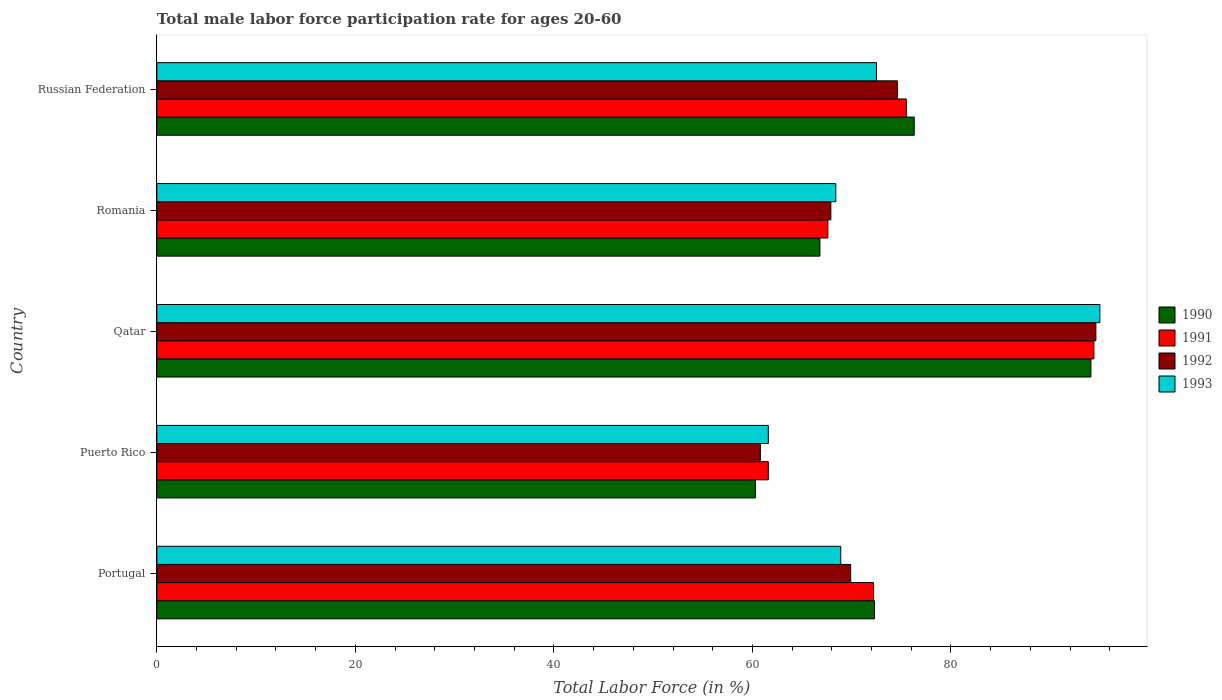How many groups of bars are there?
Provide a short and direct response. 5. Are the number of bars on each tick of the Y-axis equal?
Offer a very short reply. Yes. How many bars are there on the 3rd tick from the top?
Provide a succinct answer. 4. What is the label of the 1st group of bars from the top?
Offer a very short reply. Russian Federation. What is the male labor force participation rate in 1991 in Puerto Rico?
Give a very brief answer. 61.6. Across all countries, what is the maximum male labor force participation rate in 1992?
Provide a short and direct response. 94.6. Across all countries, what is the minimum male labor force participation rate in 1991?
Keep it short and to the point. 61.6. In which country was the male labor force participation rate in 1993 maximum?
Provide a succinct answer. Qatar. In which country was the male labor force participation rate in 1990 minimum?
Provide a succinct answer. Puerto Rico. What is the total male labor force participation rate in 1990 in the graph?
Offer a terse response. 369.8. What is the difference between the male labor force participation rate in 1993 in Puerto Rico and that in Qatar?
Give a very brief answer. -33.4. What is the difference between the male labor force participation rate in 1993 in Russian Federation and the male labor force participation rate in 1991 in Puerto Rico?
Ensure brevity in your answer.  10.9. What is the average male labor force participation rate in 1990 per country?
Provide a succinct answer. 73.96. What is the difference between the male labor force participation rate in 1992 and male labor force participation rate in 1990 in Russian Federation?
Keep it short and to the point. -1.7. In how many countries, is the male labor force participation rate in 1991 greater than 68 %?
Keep it short and to the point. 3. What is the ratio of the male labor force participation rate in 1991 in Puerto Rico to that in Romania?
Ensure brevity in your answer.  0.91. Is the male labor force participation rate in 1993 in Portugal less than that in Romania?
Make the answer very short. No. What is the difference between the highest and the second highest male labor force participation rate in 1993?
Make the answer very short. 22.5. What is the difference between the highest and the lowest male labor force participation rate in 1992?
Offer a terse response. 33.8. In how many countries, is the male labor force participation rate in 1993 greater than the average male labor force participation rate in 1993 taken over all countries?
Keep it short and to the point. 1. Is it the case that in every country, the sum of the male labor force participation rate in 1991 and male labor force participation rate in 1992 is greater than the sum of male labor force participation rate in 1993 and male labor force participation rate in 1990?
Give a very brief answer. No. What does the 4th bar from the top in Puerto Rico represents?
Ensure brevity in your answer.  1990. What does the 4th bar from the bottom in Russian Federation represents?
Provide a short and direct response. 1993. Are all the bars in the graph horizontal?
Give a very brief answer. Yes. Where does the legend appear in the graph?
Your answer should be compact. Center right. How many legend labels are there?
Keep it short and to the point. 4. What is the title of the graph?
Keep it short and to the point. Total male labor force participation rate for ages 20-60. Does "1990" appear as one of the legend labels in the graph?
Your response must be concise. Yes. What is the label or title of the X-axis?
Ensure brevity in your answer.  Total Labor Force (in %). What is the label or title of the Y-axis?
Ensure brevity in your answer.  Country. What is the Total Labor Force (in %) of 1990 in Portugal?
Provide a short and direct response. 72.3. What is the Total Labor Force (in %) in 1991 in Portugal?
Provide a succinct answer. 72.2. What is the Total Labor Force (in %) of 1992 in Portugal?
Your response must be concise. 69.9. What is the Total Labor Force (in %) of 1993 in Portugal?
Make the answer very short. 68.9. What is the Total Labor Force (in %) in 1990 in Puerto Rico?
Provide a short and direct response. 60.3. What is the Total Labor Force (in %) of 1991 in Puerto Rico?
Your answer should be compact. 61.6. What is the Total Labor Force (in %) of 1992 in Puerto Rico?
Offer a very short reply. 60.8. What is the Total Labor Force (in %) in 1993 in Puerto Rico?
Your answer should be very brief. 61.6. What is the Total Labor Force (in %) of 1990 in Qatar?
Your answer should be compact. 94.1. What is the Total Labor Force (in %) in 1991 in Qatar?
Keep it short and to the point. 94.4. What is the Total Labor Force (in %) in 1992 in Qatar?
Keep it short and to the point. 94.6. What is the Total Labor Force (in %) of 1990 in Romania?
Give a very brief answer. 66.8. What is the Total Labor Force (in %) in 1991 in Romania?
Your answer should be compact. 67.6. What is the Total Labor Force (in %) in 1992 in Romania?
Ensure brevity in your answer.  67.9. What is the Total Labor Force (in %) in 1993 in Romania?
Your response must be concise. 68.4. What is the Total Labor Force (in %) in 1990 in Russian Federation?
Keep it short and to the point. 76.3. What is the Total Labor Force (in %) of 1991 in Russian Federation?
Offer a very short reply. 75.5. What is the Total Labor Force (in %) of 1992 in Russian Federation?
Offer a terse response. 74.6. What is the Total Labor Force (in %) in 1993 in Russian Federation?
Offer a very short reply. 72.5. Across all countries, what is the maximum Total Labor Force (in %) of 1990?
Your response must be concise. 94.1. Across all countries, what is the maximum Total Labor Force (in %) of 1991?
Offer a terse response. 94.4. Across all countries, what is the maximum Total Labor Force (in %) of 1992?
Offer a terse response. 94.6. Across all countries, what is the maximum Total Labor Force (in %) in 1993?
Ensure brevity in your answer.  95. Across all countries, what is the minimum Total Labor Force (in %) of 1990?
Make the answer very short. 60.3. Across all countries, what is the minimum Total Labor Force (in %) of 1991?
Your response must be concise. 61.6. Across all countries, what is the minimum Total Labor Force (in %) in 1992?
Ensure brevity in your answer.  60.8. Across all countries, what is the minimum Total Labor Force (in %) in 1993?
Provide a succinct answer. 61.6. What is the total Total Labor Force (in %) in 1990 in the graph?
Provide a succinct answer. 369.8. What is the total Total Labor Force (in %) in 1991 in the graph?
Ensure brevity in your answer.  371.3. What is the total Total Labor Force (in %) in 1992 in the graph?
Keep it short and to the point. 367.8. What is the total Total Labor Force (in %) in 1993 in the graph?
Make the answer very short. 366.4. What is the difference between the Total Labor Force (in %) of 1992 in Portugal and that in Puerto Rico?
Your answer should be compact. 9.1. What is the difference between the Total Labor Force (in %) in 1993 in Portugal and that in Puerto Rico?
Your answer should be very brief. 7.3. What is the difference between the Total Labor Force (in %) in 1990 in Portugal and that in Qatar?
Keep it short and to the point. -21.8. What is the difference between the Total Labor Force (in %) of 1991 in Portugal and that in Qatar?
Your answer should be very brief. -22.2. What is the difference between the Total Labor Force (in %) in 1992 in Portugal and that in Qatar?
Give a very brief answer. -24.7. What is the difference between the Total Labor Force (in %) in 1993 in Portugal and that in Qatar?
Offer a terse response. -26.1. What is the difference between the Total Labor Force (in %) in 1990 in Portugal and that in Romania?
Make the answer very short. 5.5. What is the difference between the Total Labor Force (in %) of 1993 in Portugal and that in Romania?
Make the answer very short. 0.5. What is the difference between the Total Labor Force (in %) of 1990 in Puerto Rico and that in Qatar?
Your response must be concise. -33.8. What is the difference between the Total Labor Force (in %) of 1991 in Puerto Rico and that in Qatar?
Provide a succinct answer. -32.8. What is the difference between the Total Labor Force (in %) of 1992 in Puerto Rico and that in Qatar?
Offer a terse response. -33.8. What is the difference between the Total Labor Force (in %) in 1993 in Puerto Rico and that in Qatar?
Your answer should be compact. -33.4. What is the difference between the Total Labor Force (in %) of 1990 in Puerto Rico and that in Romania?
Ensure brevity in your answer.  -6.5. What is the difference between the Total Labor Force (in %) in 1991 in Puerto Rico and that in Romania?
Provide a short and direct response. -6. What is the difference between the Total Labor Force (in %) of 1991 in Puerto Rico and that in Russian Federation?
Make the answer very short. -13.9. What is the difference between the Total Labor Force (in %) in 1993 in Puerto Rico and that in Russian Federation?
Your response must be concise. -10.9. What is the difference between the Total Labor Force (in %) of 1990 in Qatar and that in Romania?
Provide a succinct answer. 27.3. What is the difference between the Total Labor Force (in %) of 1991 in Qatar and that in Romania?
Provide a succinct answer. 26.8. What is the difference between the Total Labor Force (in %) in 1992 in Qatar and that in Romania?
Provide a short and direct response. 26.7. What is the difference between the Total Labor Force (in %) in 1993 in Qatar and that in Romania?
Your answer should be very brief. 26.6. What is the difference between the Total Labor Force (in %) of 1990 in Qatar and that in Russian Federation?
Your response must be concise. 17.8. What is the difference between the Total Labor Force (in %) in 1991 in Qatar and that in Russian Federation?
Your response must be concise. 18.9. What is the difference between the Total Labor Force (in %) of 1991 in Romania and that in Russian Federation?
Your answer should be compact. -7.9. What is the difference between the Total Labor Force (in %) of 1993 in Romania and that in Russian Federation?
Offer a very short reply. -4.1. What is the difference between the Total Labor Force (in %) in 1990 in Portugal and the Total Labor Force (in %) in 1991 in Puerto Rico?
Provide a short and direct response. 10.7. What is the difference between the Total Labor Force (in %) in 1991 in Portugal and the Total Labor Force (in %) in 1992 in Puerto Rico?
Offer a terse response. 11.4. What is the difference between the Total Labor Force (in %) in 1991 in Portugal and the Total Labor Force (in %) in 1993 in Puerto Rico?
Ensure brevity in your answer.  10.6. What is the difference between the Total Labor Force (in %) of 1990 in Portugal and the Total Labor Force (in %) of 1991 in Qatar?
Your answer should be very brief. -22.1. What is the difference between the Total Labor Force (in %) of 1990 in Portugal and the Total Labor Force (in %) of 1992 in Qatar?
Offer a terse response. -22.3. What is the difference between the Total Labor Force (in %) of 1990 in Portugal and the Total Labor Force (in %) of 1993 in Qatar?
Give a very brief answer. -22.7. What is the difference between the Total Labor Force (in %) of 1991 in Portugal and the Total Labor Force (in %) of 1992 in Qatar?
Offer a terse response. -22.4. What is the difference between the Total Labor Force (in %) of 1991 in Portugal and the Total Labor Force (in %) of 1993 in Qatar?
Make the answer very short. -22.8. What is the difference between the Total Labor Force (in %) of 1992 in Portugal and the Total Labor Force (in %) of 1993 in Qatar?
Provide a succinct answer. -25.1. What is the difference between the Total Labor Force (in %) in 1990 in Portugal and the Total Labor Force (in %) in 1991 in Romania?
Offer a very short reply. 4.7. What is the difference between the Total Labor Force (in %) of 1990 in Portugal and the Total Labor Force (in %) of 1993 in Romania?
Keep it short and to the point. 3.9. What is the difference between the Total Labor Force (in %) in 1991 in Portugal and the Total Labor Force (in %) in 1992 in Romania?
Ensure brevity in your answer.  4.3. What is the difference between the Total Labor Force (in %) in 1991 in Portugal and the Total Labor Force (in %) in 1993 in Romania?
Offer a very short reply. 3.8. What is the difference between the Total Labor Force (in %) of 1992 in Portugal and the Total Labor Force (in %) of 1993 in Romania?
Keep it short and to the point. 1.5. What is the difference between the Total Labor Force (in %) in 1990 in Portugal and the Total Labor Force (in %) in 1991 in Russian Federation?
Give a very brief answer. -3.2. What is the difference between the Total Labor Force (in %) of 1990 in Portugal and the Total Labor Force (in %) of 1992 in Russian Federation?
Ensure brevity in your answer.  -2.3. What is the difference between the Total Labor Force (in %) in 1990 in Portugal and the Total Labor Force (in %) in 1993 in Russian Federation?
Your response must be concise. -0.2. What is the difference between the Total Labor Force (in %) in 1991 in Portugal and the Total Labor Force (in %) in 1992 in Russian Federation?
Your response must be concise. -2.4. What is the difference between the Total Labor Force (in %) of 1992 in Portugal and the Total Labor Force (in %) of 1993 in Russian Federation?
Offer a terse response. -2.6. What is the difference between the Total Labor Force (in %) of 1990 in Puerto Rico and the Total Labor Force (in %) of 1991 in Qatar?
Provide a short and direct response. -34.1. What is the difference between the Total Labor Force (in %) in 1990 in Puerto Rico and the Total Labor Force (in %) in 1992 in Qatar?
Provide a succinct answer. -34.3. What is the difference between the Total Labor Force (in %) of 1990 in Puerto Rico and the Total Labor Force (in %) of 1993 in Qatar?
Make the answer very short. -34.7. What is the difference between the Total Labor Force (in %) of 1991 in Puerto Rico and the Total Labor Force (in %) of 1992 in Qatar?
Keep it short and to the point. -33. What is the difference between the Total Labor Force (in %) of 1991 in Puerto Rico and the Total Labor Force (in %) of 1993 in Qatar?
Ensure brevity in your answer.  -33.4. What is the difference between the Total Labor Force (in %) in 1992 in Puerto Rico and the Total Labor Force (in %) in 1993 in Qatar?
Make the answer very short. -34.2. What is the difference between the Total Labor Force (in %) in 1990 in Puerto Rico and the Total Labor Force (in %) in 1992 in Romania?
Ensure brevity in your answer.  -7.6. What is the difference between the Total Labor Force (in %) in 1990 in Puerto Rico and the Total Labor Force (in %) in 1993 in Romania?
Ensure brevity in your answer.  -8.1. What is the difference between the Total Labor Force (in %) in 1991 in Puerto Rico and the Total Labor Force (in %) in 1993 in Romania?
Offer a very short reply. -6.8. What is the difference between the Total Labor Force (in %) in 1992 in Puerto Rico and the Total Labor Force (in %) in 1993 in Romania?
Keep it short and to the point. -7.6. What is the difference between the Total Labor Force (in %) in 1990 in Puerto Rico and the Total Labor Force (in %) in 1991 in Russian Federation?
Provide a short and direct response. -15.2. What is the difference between the Total Labor Force (in %) in 1990 in Puerto Rico and the Total Labor Force (in %) in 1992 in Russian Federation?
Provide a succinct answer. -14.3. What is the difference between the Total Labor Force (in %) in 1990 in Puerto Rico and the Total Labor Force (in %) in 1993 in Russian Federation?
Your response must be concise. -12.2. What is the difference between the Total Labor Force (in %) of 1990 in Qatar and the Total Labor Force (in %) of 1992 in Romania?
Offer a terse response. 26.2. What is the difference between the Total Labor Force (in %) of 1990 in Qatar and the Total Labor Force (in %) of 1993 in Romania?
Offer a terse response. 25.7. What is the difference between the Total Labor Force (in %) of 1992 in Qatar and the Total Labor Force (in %) of 1993 in Romania?
Your answer should be very brief. 26.2. What is the difference between the Total Labor Force (in %) of 1990 in Qatar and the Total Labor Force (in %) of 1992 in Russian Federation?
Your answer should be compact. 19.5. What is the difference between the Total Labor Force (in %) of 1990 in Qatar and the Total Labor Force (in %) of 1993 in Russian Federation?
Make the answer very short. 21.6. What is the difference between the Total Labor Force (in %) of 1991 in Qatar and the Total Labor Force (in %) of 1992 in Russian Federation?
Ensure brevity in your answer.  19.8. What is the difference between the Total Labor Force (in %) of 1991 in Qatar and the Total Labor Force (in %) of 1993 in Russian Federation?
Keep it short and to the point. 21.9. What is the difference between the Total Labor Force (in %) of 1992 in Qatar and the Total Labor Force (in %) of 1993 in Russian Federation?
Make the answer very short. 22.1. What is the difference between the Total Labor Force (in %) of 1990 in Romania and the Total Labor Force (in %) of 1993 in Russian Federation?
Offer a very short reply. -5.7. What is the difference between the Total Labor Force (in %) in 1991 in Romania and the Total Labor Force (in %) in 1992 in Russian Federation?
Give a very brief answer. -7. What is the average Total Labor Force (in %) in 1990 per country?
Ensure brevity in your answer.  73.96. What is the average Total Labor Force (in %) in 1991 per country?
Give a very brief answer. 74.26. What is the average Total Labor Force (in %) in 1992 per country?
Offer a very short reply. 73.56. What is the average Total Labor Force (in %) of 1993 per country?
Your answer should be compact. 73.28. What is the difference between the Total Labor Force (in %) in 1990 and Total Labor Force (in %) in 1991 in Portugal?
Provide a short and direct response. 0.1. What is the difference between the Total Labor Force (in %) in 1990 and Total Labor Force (in %) in 1992 in Portugal?
Make the answer very short. 2.4. What is the difference between the Total Labor Force (in %) in 1992 and Total Labor Force (in %) in 1993 in Portugal?
Provide a succinct answer. 1. What is the difference between the Total Labor Force (in %) of 1990 and Total Labor Force (in %) of 1991 in Puerto Rico?
Your response must be concise. -1.3. What is the difference between the Total Labor Force (in %) in 1991 and Total Labor Force (in %) in 1992 in Puerto Rico?
Make the answer very short. 0.8. What is the difference between the Total Labor Force (in %) of 1992 and Total Labor Force (in %) of 1993 in Puerto Rico?
Your answer should be very brief. -0.8. What is the difference between the Total Labor Force (in %) in 1991 and Total Labor Force (in %) in 1992 in Qatar?
Your response must be concise. -0.2. What is the difference between the Total Labor Force (in %) in 1992 and Total Labor Force (in %) in 1993 in Qatar?
Keep it short and to the point. -0.4. What is the difference between the Total Labor Force (in %) of 1990 and Total Labor Force (in %) of 1991 in Romania?
Your response must be concise. -0.8. What is the difference between the Total Labor Force (in %) in 1991 and Total Labor Force (in %) in 1992 in Romania?
Offer a terse response. -0.3. What is the difference between the Total Labor Force (in %) of 1991 and Total Labor Force (in %) of 1993 in Romania?
Your answer should be compact. -0.8. What is the difference between the Total Labor Force (in %) of 1990 and Total Labor Force (in %) of 1991 in Russian Federation?
Your answer should be compact. 0.8. What is the difference between the Total Labor Force (in %) of 1990 and Total Labor Force (in %) of 1993 in Russian Federation?
Give a very brief answer. 3.8. What is the ratio of the Total Labor Force (in %) in 1990 in Portugal to that in Puerto Rico?
Your answer should be compact. 1.2. What is the ratio of the Total Labor Force (in %) in 1991 in Portugal to that in Puerto Rico?
Keep it short and to the point. 1.17. What is the ratio of the Total Labor Force (in %) of 1992 in Portugal to that in Puerto Rico?
Ensure brevity in your answer.  1.15. What is the ratio of the Total Labor Force (in %) in 1993 in Portugal to that in Puerto Rico?
Keep it short and to the point. 1.12. What is the ratio of the Total Labor Force (in %) in 1990 in Portugal to that in Qatar?
Provide a short and direct response. 0.77. What is the ratio of the Total Labor Force (in %) of 1991 in Portugal to that in Qatar?
Keep it short and to the point. 0.76. What is the ratio of the Total Labor Force (in %) in 1992 in Portugal to that in Qatar?
Your answer should be compact. 0.74. What is the ratio of the Total Labor Force (in %) of 1993 in Portugal to that in Qatar?
Keep it short and to the point. 0.73. What is the ratio of the Total Labor Force (in %) in 1990 in Portugal to that in Romania?
Your response must be concise. 1.08. What is the ratio of the Total Labor Force (in %) in 1991 in Portugal to that in Romania?
Your response must be concise. 1.07. What is the ratio of the Total Labor Force (in %) of 1992 in Portugal to that in Romania?
Keep it short and to the point. 1.03. What is the ratio of the Total Labor Force (in %) of 1993 in Portugal to that in Romania?
Your response must be concise. 1.01. What is the ratio of the Total Labor Force (in %) in 1990 in Portugal to that in Russian Federation?
Ensure brevity in your answer.  0.95. What is the ratio of the Total Labor Force (in %) in 1991 in Portugal to that in Russian Federation?
Your answer should be very brief. 0.96. What is the ratio of the Total Labor Force (in %) in 1992 in Portugal to that in Russian Federation?
Ensure brevity in your answer.  0.94. What is the ratio of the Total Labor Force (in %) in 1993 in Portugal to that in Russian Federation?
Your answer should be compact. 0.95. What is the ratio of the Total Labor Force (in %) in 1990 in Puerto Rico to that in Qatar?
Your answer should be compact. 0.64. What is the ratio of the Total Labor Force (in %) of 1991 in Puerto Rico to that in Qatar?
Your response must be concise. 0.65. What is the ratio of the Total Labor Force (in %) of 1992 in Puerto Rico to that in Qatar?
Keep it short and to the point. 0.64. What is the ratio of the Total Labor Force (in %) in 1993 in Puerto Rico to that in Qatar?
Ensure brevity in your answer.  0.65. What is the ratio of the Total Labor Force (in %) in 1990 in Puerto Rico to that in Romania?
Provide a succinct answer. 0.9. What is the ratio of the Total Labor Force (in %) of 1991 in Puerto Rico to that in Romania?
Your answer should be very brief. 0.91. What is the ratio of the Total Labor Force (in %) of 1992 in Puerto Rico to that in Romania?
Make the answer very short. 0.9. What is the ratio of the Total Labor Force (in %) of 1993 in Puerto Rico to that in Romania?
Ensure brevity in your answer.  0.9. What is the ratio of the Total Labor Force (in %) of 1990 in Puerto Rico to that in Russian Federation?
Give a very brief answer. 0.79. What is the ratio of the Total Labor Force (in %) in 1991 in Puerto Rico to that in Russian Federation?
Provide a short and direct response. 0.82. What is the ratio of the Total Labor Force (in %) of 1992 in Puerto Rico to that in Russian Federation?
Offer a terse response. 0.81. What is the ratio of the Total Labor Force (in %) of 1993 in Puerto Rico to that in Russian Federation?
Your response must be concise. 0.85. What is the ratio of the Total Labor Force (in %) of 1990 in Qatar to that in Romania?
Ensure brevity in your answer.  1.41. What is the ratio of the Total Labor Force (in %) of 1991 in Qatar to that in Romania?
Provide a short and direct response. 1.4. What is the ratio of the Total Labor Force (in %) of 1992 in Qatar to that in Romania?
Give a very brief answer. 1.39. What is the ratio of the Total Labor Force (in %) in 1993 in Qatar to that in Romania?
Offer a terse response. 1.39. What is the ratio of the Total Labor Force (in %) in 1990 in Qatar to that in Russian Federation?
Keep it short and to the point. 1.23. What is the ratio of the Total Labor Force (in %) of 1991 in Qatar to that in Russian Federation?
Give a very brief answer. 1.25. What is the ratio of the Total Labor Force (in %) of 1992 in Qatar to that in Russian Federation?
Keep it short and to the point. 1.27. What is the ratio of the Total Labor Force (in %) of 1993 in Qatar to that in Russian Federation?
Offer a very short reply. 1.31. What is the ratio of the Total Labor Force (in %) in 1990 in Romania to that in Russian Federation?
Ensure brevity in your answer.  0.88. What is the ratio of the Total Labor Force (in %) of 1991 in Romania to that in Russian Federation?
Your response must be concise. 0.9. What is the ratio of the Total Labor Force (in %) of 1992 in Romania to that in Russian Federation?
Provide a short and direct response. 0.91. What is the ratio of the Total Labor Force (in %) in 1993 in Romania to that in Russian Federation?
Your answer should be very brief. 0.94. What is the difference between the highest and the second highest Total Labor Force (in %) of 1992?
Offer a very short reply. 20. What is the difference between the highest and the second highest Total Labor Force (in %) of 1993?
Provide a short and direct response. 22.5. What is the difference between the highest and the lowest Total Labor Force (in %) of 1990?
Provide a short and direct response. 33.8. What is the difference between the highest and the lowest Total Labor Force (in %) of 1991?
Provide a succinct answer. 32.8. What is the difference between the highest and the lowest Total Labor Force (in %) in 1992?
Offer a terse response. 33.8. What is the difference between the highest and the lowest Total Labor Force (in %) in 1993?
Offer a terse response. 33.4. 